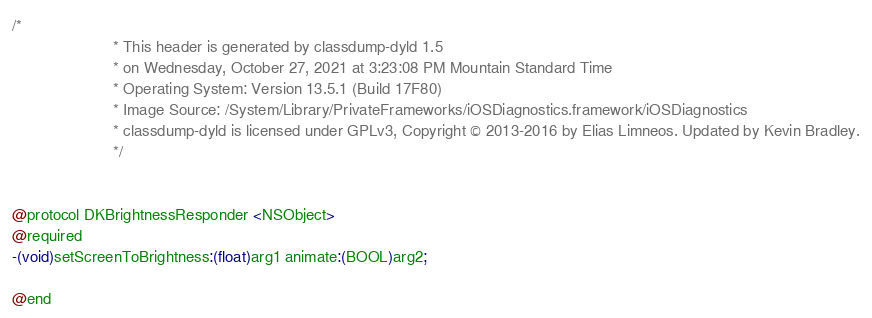Convert code to text. <code><loc_0><loc_0><loc_500><loc_500><_C_>/*
                       * This header is generated by classdump-dyld 1.5
                       * on Wednesday, October 27, 2021 at 3:23:08 PM Mountain Standard Time
                       * Operating System: Version 13.5.1 (Build 17F80)
                       * Image Source: /System/Library/PrivateFrameworks/iOSDiagnostics.framework/iOSDiagnostics
                       * classdump-dyld is licensed under GPLv3, Copyright © 2013-2016 by Elias Limneos. Updated by Kevin Bradley.
                       */


@protocol DKBrightnessResponder <NSObject>
@required
-(void)setScreenToBrightness:(float)arg1 animate:(BOOL)arg2;

@end

</code> 